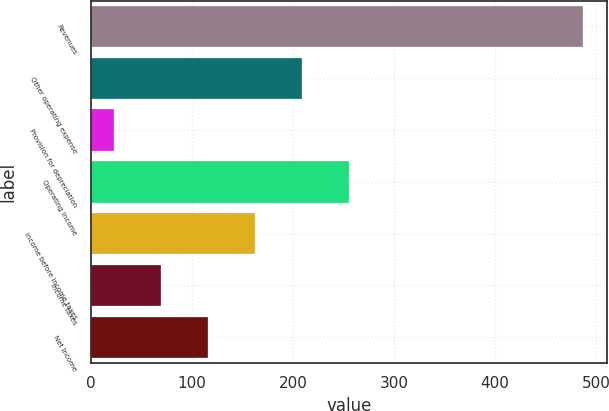Convert chart to OTSL. <chart><loc_0><loc_0><loc_500><loc_500><bar_chart><fcel>Revenues<fcel>Other operating expense<fcel>Provision for depreciation<fcel>Operating Income<fcel>Income before income taxes<fcel>Income taxes<fcel>Net Income<nl><fcel>487<fcel>208.6<fcel>23<fcel>255<fcel>162.2<fcel>69.4<fcel>115.8<nl></chart> 